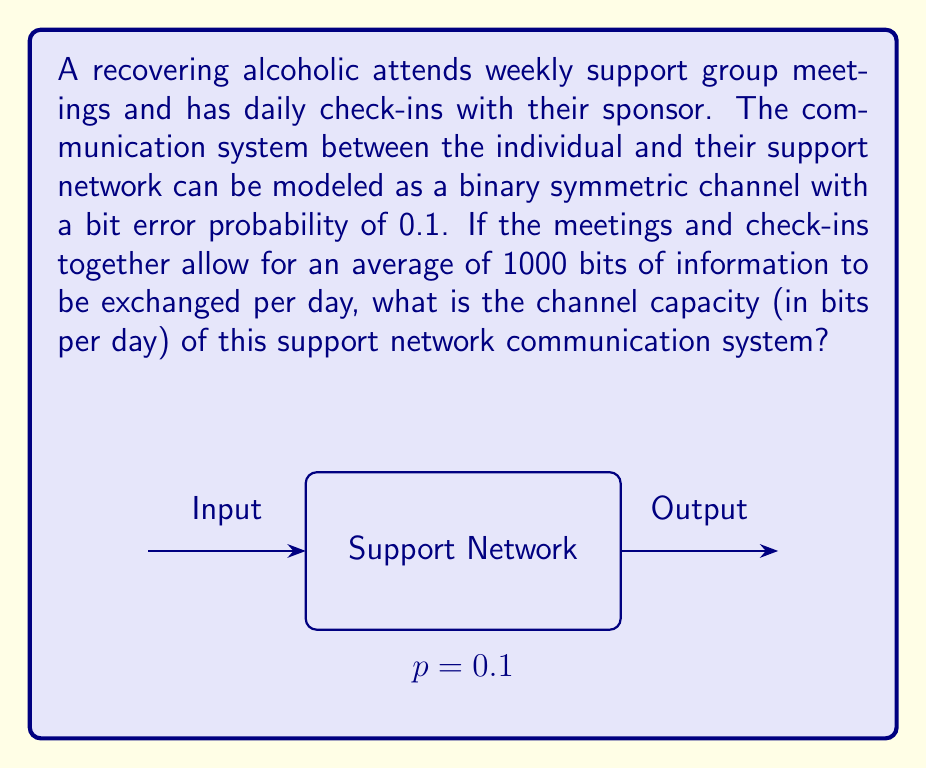Provide a solution to this math problem. To solve this problem, we'll use the channel capacity formula for a binary symmetric channel and apply it to the given scenario. Let's break it down step-by-step:

1) The channel capacity (C) for a binary symmetric channel is given by:

   $$C = 1 - H(p)$$

   where H(p) is the binary entropy function and p is the bit error probability.

2) The binary entropy function H(p) is defined as:

   $$H(p) = -p \log_2(p) - (1-p) \log_2(1-p)$$

3) Given:
   - Bit error probability (p) = 0.1
   - Average information exchanged = 1000 bits per day

4) Let's calculate H(0.1):

   $$H(0.1) = -0.1 \log_2(0.1) - 0.9 \log_2(0.9)$$
   $$= -0.1 \times (-3.32) - 0.9 \times (-0.15)$$
   $$= 0.332 + 0.135 = 0.467$$

5) Now we can calculate the channel capacity:

   $$C = 1 - H(0.1) = 1 - 0.467 = 0.533$$

6) This means that for each bit transmitted, 0.533 bits of information can be reliably communicated.

7) Given that 1000 bits are exchanged per day, the total channel capacity in bits per day is:

   $$\text{Channel Capacity} = 1000 \times 0.533 = 533 \text{ bits per day}$$

This result indicates the maximum rate at which information can be reliably transmitted through the support network communication system, taking into account the probability of miscommunication or misunderstanding.
Answer: 533 bits per day 